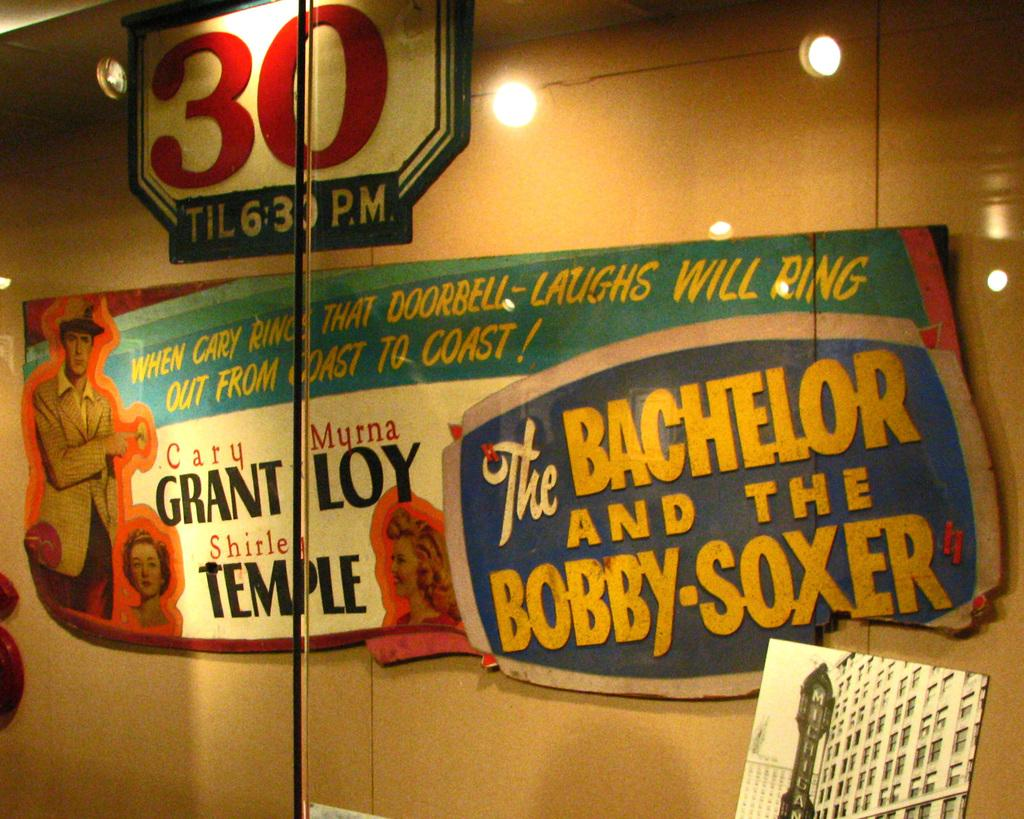What is attached to the wall in the image? There is a board fixed to the wall in the image. What can be seen on the board? There is text on the board. What can be seen illuminating the area in the image? There are lights visible in the image. What is visible behind the board in the image? There is a wall in the background of the image. Who is the owner of the maid in the image? There is no maid or owner present in the image. 